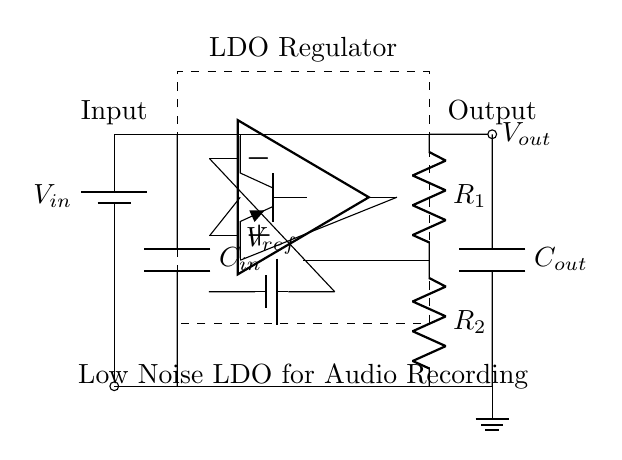What is the input voltage of the circuit? The input voltage is represented by the label "Vin" placed next to the battery symbol in the circuit.
Answer: Vin What type of regulator is shown in the circuit? The circuit is identified as a "LDO Regulator" which stands for Low-Dropout Regulator, indicated by the label above the dashed rectangle.
Answer: LDO Regulator How many resistors are in the feedback network? There are two resistors, labeled "R1" and "R2", clearly indicated in the feedback section of the diagram.
Answer: 2 What is the purpose of the capacitors in the circuit? The capacitors "Cin" and "Cout" are utilized for input and output filtering to reduce noise, ensuring stable operation in sensitive audio applications.
Answer: Noise reduction What is the function of the error amplifier in this circuit? The error amplifier compares the output voltage with the reference voltage to maintain a stable output voltage, as shown by the connections to the op-amp symbol.
Answer: Voltage regulation What is the reference voltage in this circuit? The reference voltage is represented by the label "Vref", which is clearly marked beside the battery symbol that connects to the negative input of the op-amp.
Answer: Vref What is the output voltage labeled as in the circuit? The output voltage is indicated by "Vout", which is next to the output terminal leading from the circuit.
Answer: Vout 